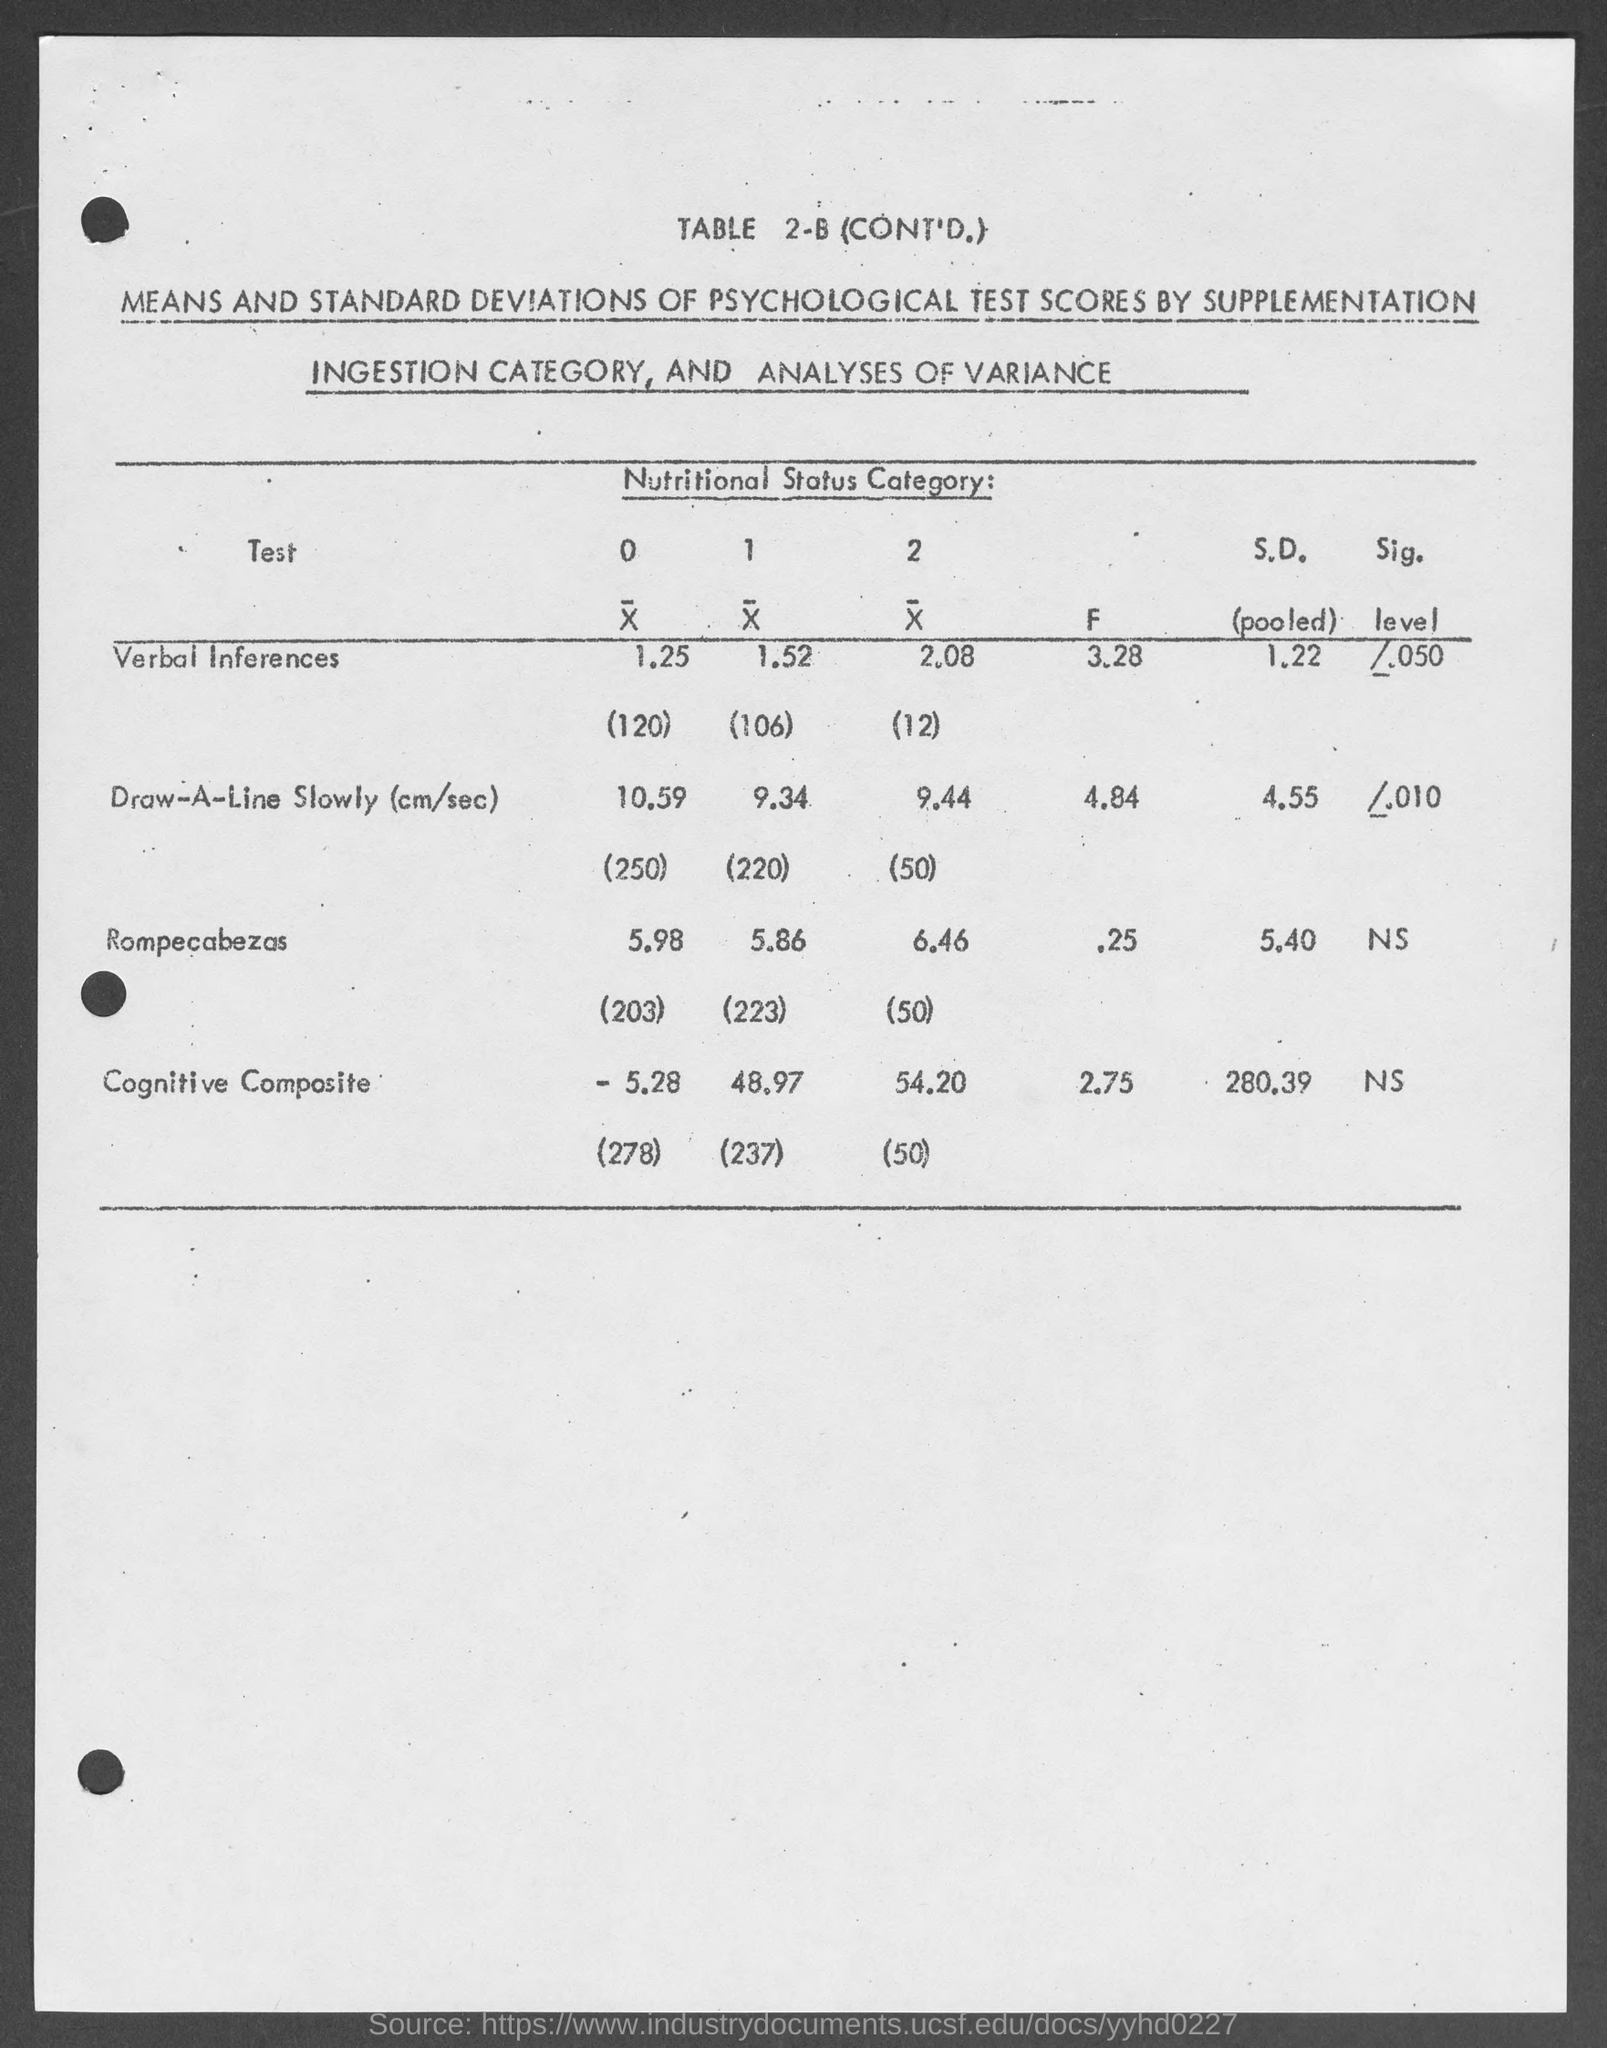What is the "S.D.(pooled)" value for test "Cognitive Composite" as per TABLE 2-B?
Your answer should be very brief. 280.39. What is the "S.D.(pooled)" value for test "Rompecabezas" as per TABLE 2-B?
Your response must be concise. 5.40. What is the "F" value for test "Verbal Inferences" as per TABLE 2-B?
Keep it short and to the point. 3.28. What is the "F" value for test "Cognitive Composite" as per TABLE 2-B?
Ensure brevity in your answer.  2.75. What is the "F" value for test "Rompecabezas" as per TABLE 2-B?
Make the answer very short. .25. What is the "S.D.(pooled)" value for test "Verbal Inferences" as per TABLE 2-B?
Your answer should be very brief. 1.22. 